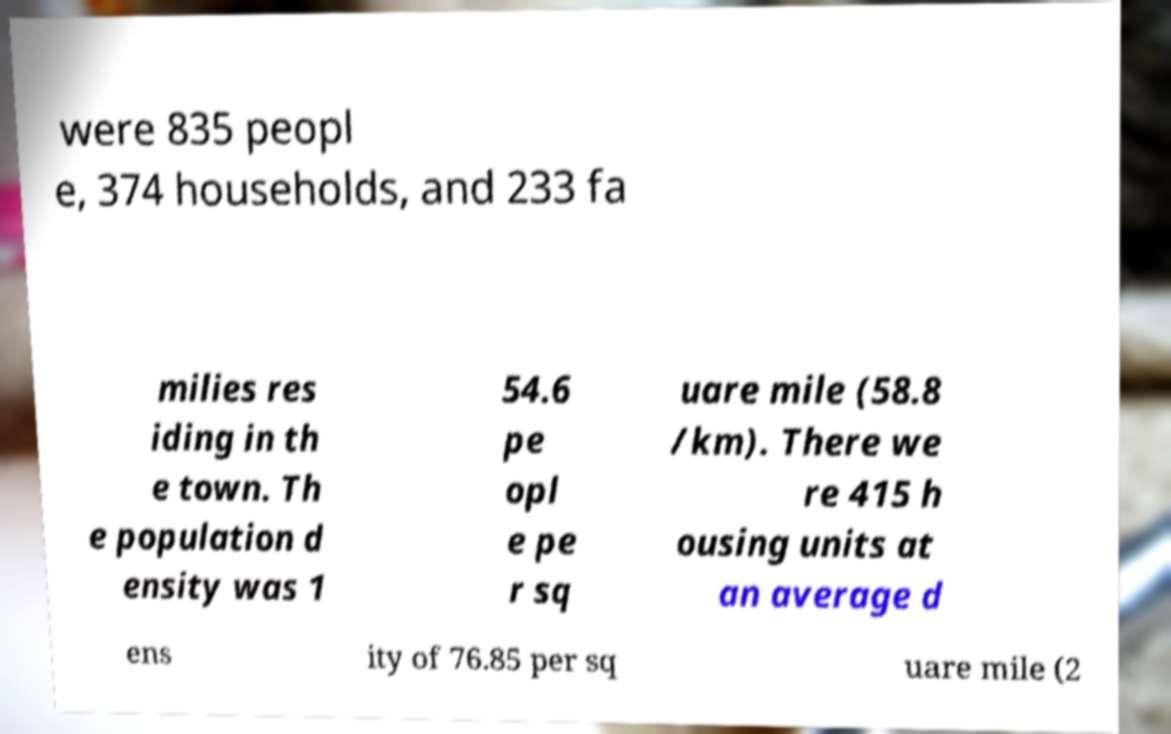Please read and relay the text visible in this image. What does it say? were 835 peopl e, 374 households, and 233 fa milies res iding in th e town. Th e population d ensity was 1 54.6 pe opl e pe r sq uare mile (58.8 /km). There we re 415 h ousing units at an average d ens ity of 76.85 per sq uare mile (2 